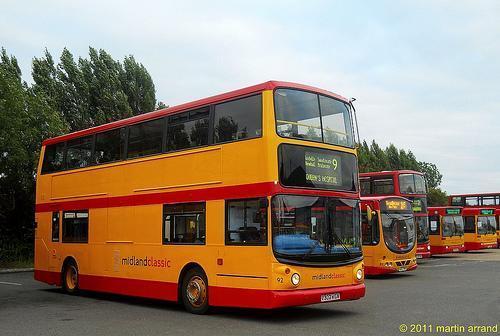How many busses are in the parking lot?
Give a very brief answer. 6. 